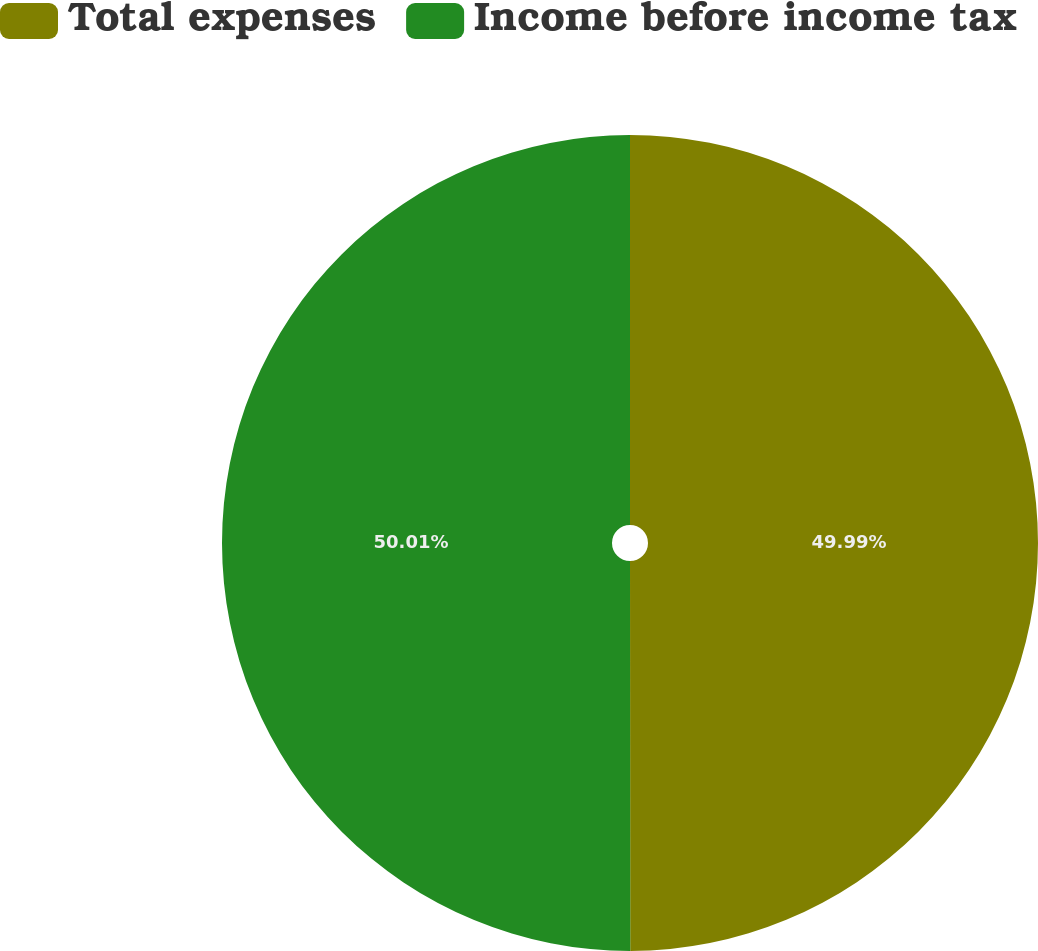Convert chart. <chart><loc_0><loc_0><loc_500><loc_500><pie_chart><fcel>Total expenses<fcel>Income before income tax<nl><fcel>49.99%<fcel>50.01%<nl></chart> 